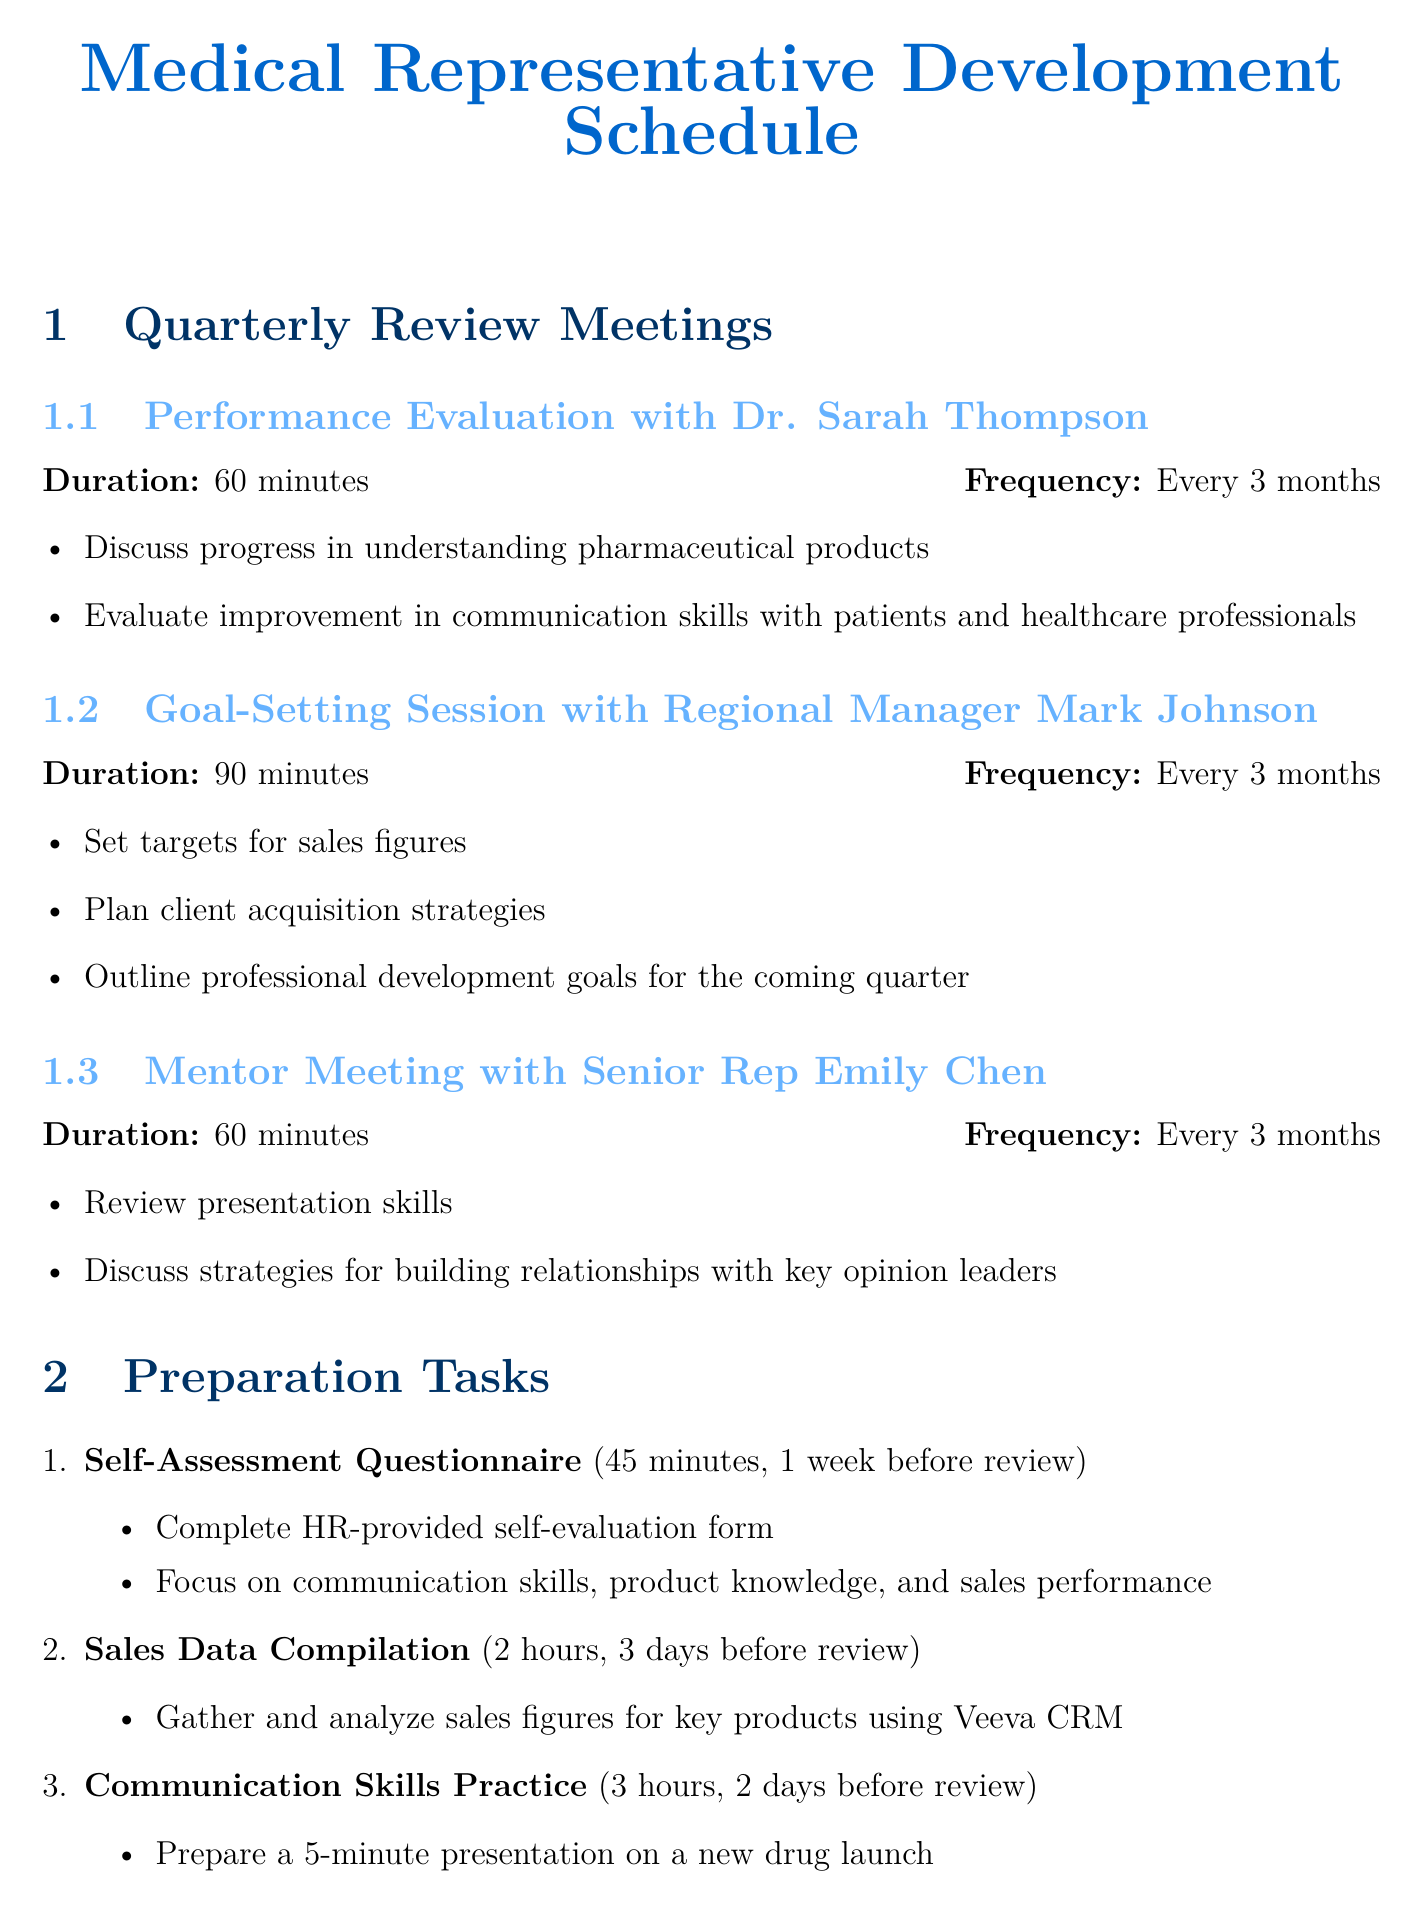What is the name of the first quarterly review meeting? The first quarterly review meeting is with Dr. Sarah Thompson.
Answer: Performance Evaluation with Dr. Sarah Thompson How long is the Goal-Setting Session? The duration of the Goal-Setting Session is specified in the document.
Answer: 90 minutes What is the main focus of the mentor meeting? The mentor meeting focuses on reviewing specific skills.
Answer: Presentation skills How often are the quarterly review meetings held? The frequency of the meetings is explicitly mentioned in the document.
Answer: Every 3 months What is the deadline for completing the Self-Assessment Questionnaire? The document provides a clear deadline for this preparation task.
Answer: 1 week before review meeting What is one example of a goal under Sales Performance Metrics? The document includes specific examples for each goal-setting area.
Answer: Increase Xarelto prescriptions by 15% in three major hospital cardiology departments What is the duration of the AstraZeneca Medical Representative Training Program? This information is directly stated in the document.
Answer: 10 hours What type of resources are included in the development resources section? The document lists various types of development resources for training.
Answer: Online course, workshop, webinar series How many influential physicians are targeted for relationship building in Professional Network Growth? The number of physicians is provided in the goal example.
Answer: Five new influential physicians 